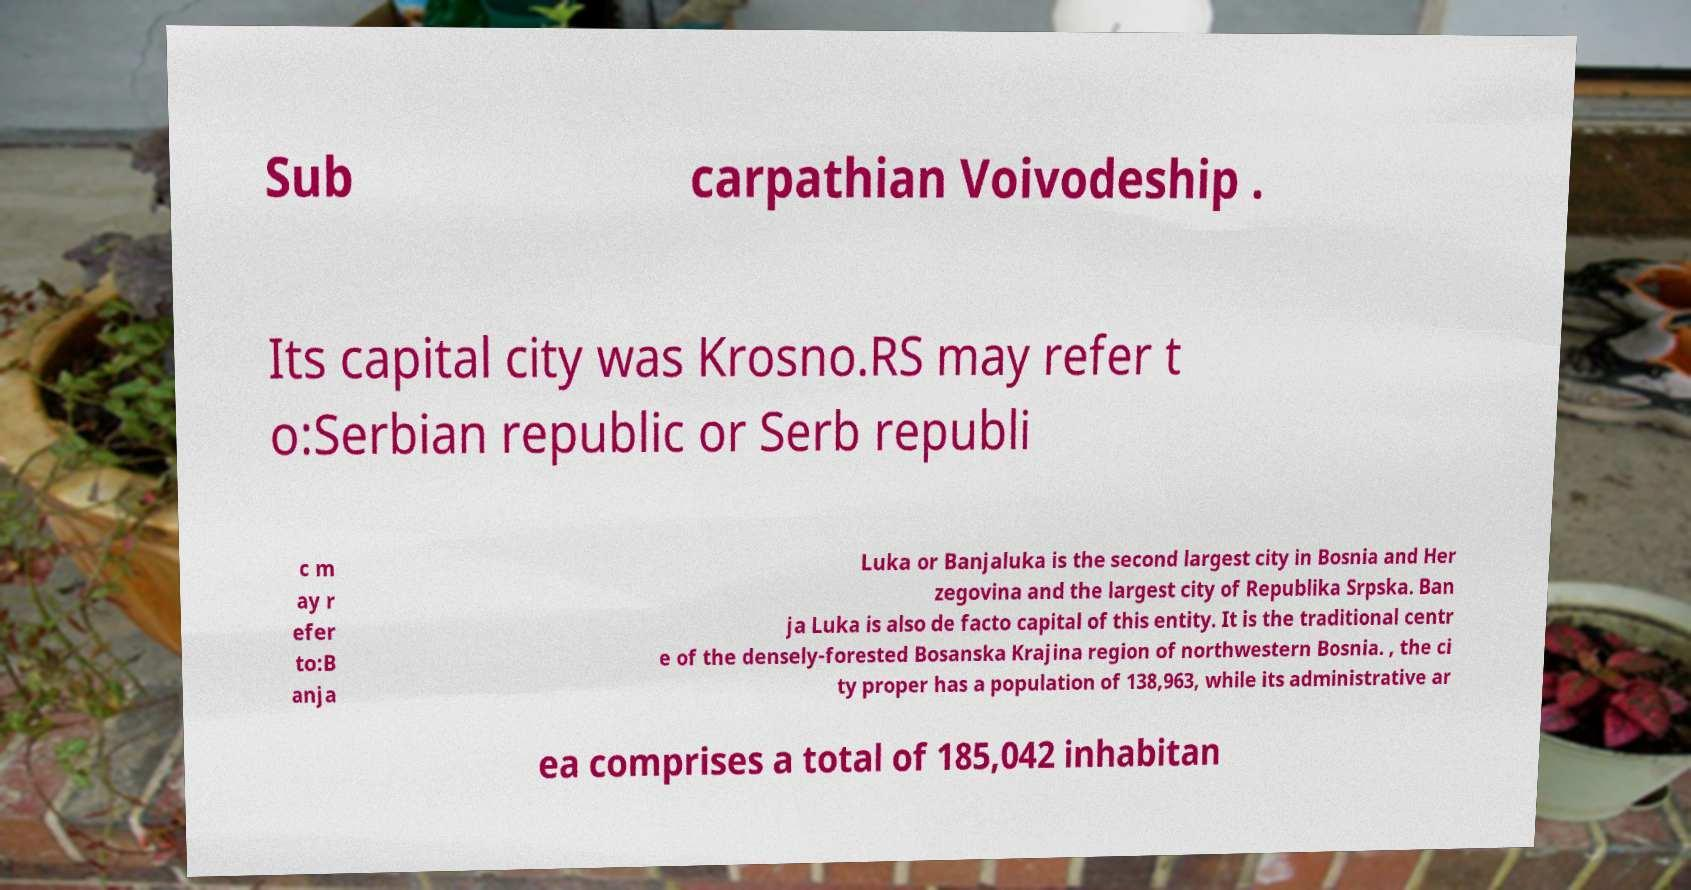Could you assist in decoding the text presented in this image and type it out clearly? Sub carpathian Voivodeship . Its capital city was Krosno.RS may refer t o:Serbian republic or Serb republi c m ay r efer to:B anja Luka or Banjaluka is the second largest city in Bosnia and Her zegovina and the largest city of Republika Srpska. Ban ja Luka is also de facto capital of this entity. It is the traditional centr e of the densely-forested Bosanska Krajina region of northwestern Bosnia. , the ci ty proper has a population of 138,963, while its administrative ar ea comprises a total of 185,042 inhabitan 